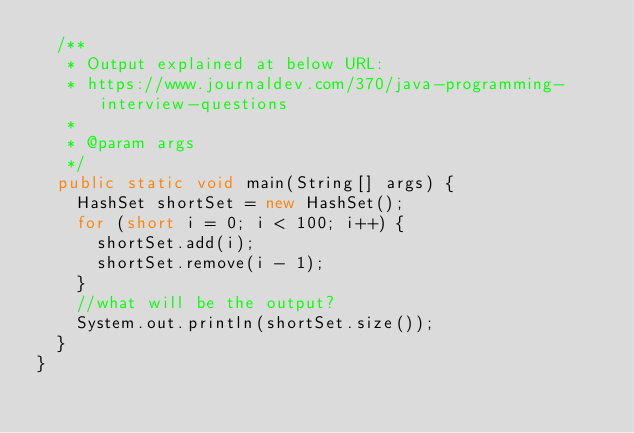<code> <loc_0><loc_0><loc_500><loc_500><_Java_>	/**
	 * Output explained at below URL:
	 * https://www.journaldev.com/370/java-programming-interview-questions
	 * 
	 * @param args
	 */
	public static void main(String[] args) {
		HashSet shortSet = new HashSet();
		for (short i = 0; i < 100; i++) {
			shortSet.add(i);
			shortSet.remove(i - 1);
		}
		//what will be the output?
		System.out.println(shortSet.size());
	}
}
</code> 